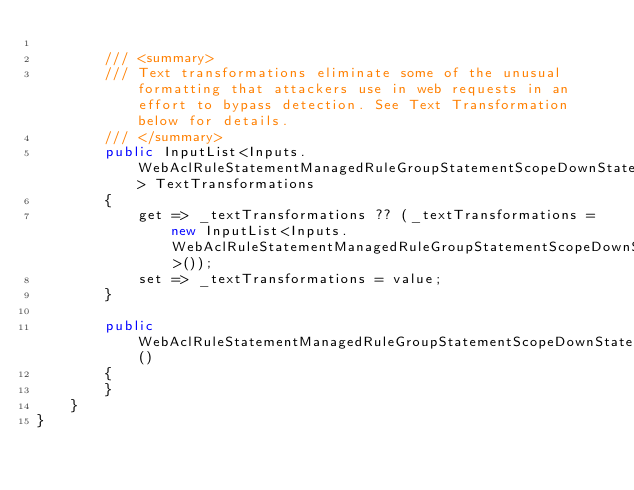Convert code to text. <code><loc_0><loc_0><loc_500><loc_500><_C#_>
        /// <summary>
        /// Text transformations eliminate some of the unusual formatting that attackers use in web requests in an effort to bypass detection. See Text Transformation below for details.
        /// </summary>
        public InputList<Inputs.WebAclRuleStatementManagedRuleGroupStatementScopeDownStatementAndStatementStatementSqliMatchStatementTextTransformationArgs> TextTransformations
        {
            get => _textTransformations ?? (_textTransformations = new InputList<Inputs.WebAclRuleStatementManagedRuleGroupStatementScopeDownStatementAndStatementStatementSqliMatchStatementTextTransformationArgs>());
            set => _textTransformations = value;
        }

        public WebAclRuleStatementManagedRuleGroupStatementScopeDownStatementAndStatementStatementSqliMatchStatementArgs()
        {
        }
    }
}
</code> 